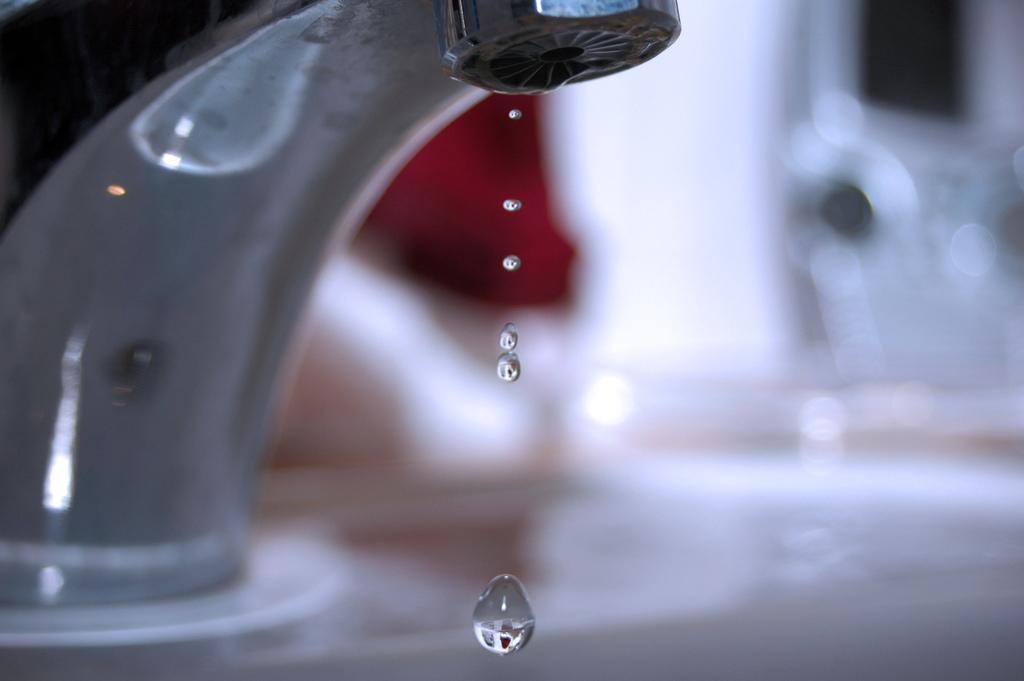What object in the image can be used to control the flow of water? There is a tap in the image that can be used to control the flow of water. What is happening to the water in the image? Water drops are visible in the image. Can you describe the background of the image? The background of the image is blurred. What type of lace can be seen on the tap in the image? There is no lace present on the tap in the image. How many threads are visible in the image? There is no reference to threads in the image, so it is not possible to determine how many are visible. 